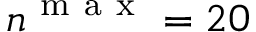Convert formula to latex. <formula><loc_0><loc_0><loc_500><loc_500>n ^ { m a x } = 2 0</formula> 